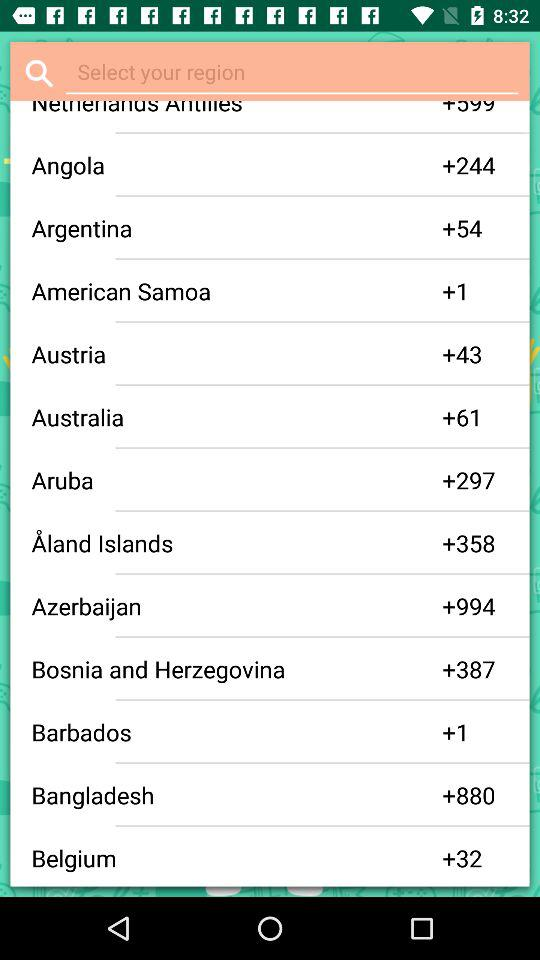What is the code for the Angola region? The Angola region code is +244. 